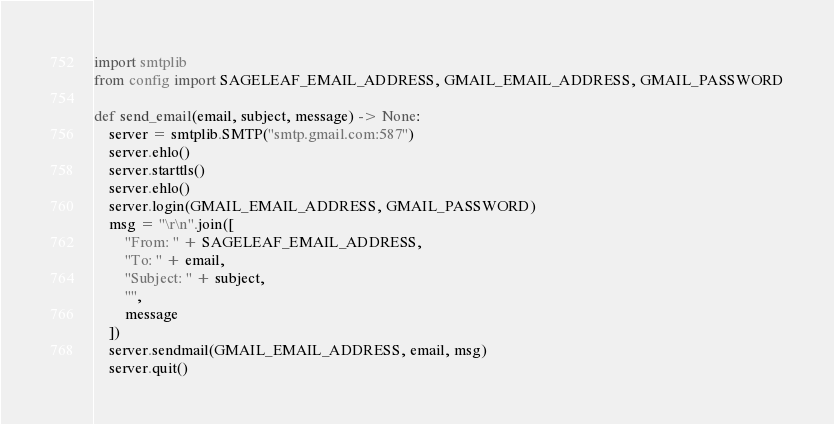<code> <loc_0><loc_0><loc_500><loc_500><_Python_>import smtplib
from config import SAGELEAF_EMAIL_ADDRESS, GMAIL_EMAIL_ADDRESS, GMAIL_PASSWORD

def send_email(email, subject, message) -> None:
    server = smtplib.SMTP("smtp.gmail.com:587")
    server.ehlo()
    server.starttls()
    server.ehlo()
    server.login(GMAIL_EMAIL_ADDRESS, GMAIL_PASSWORD)
    msg = "\r\n".join([
        "From: " + SAGELEAF_EMAIL_ADDRESS,
        "To: " + email,
        "Subject: " + subject,
        "",
        message
    ])
    server.sendmail(GMAIL_EMAIL_ADDRESS, email, msg)
    server.quit()</code> 